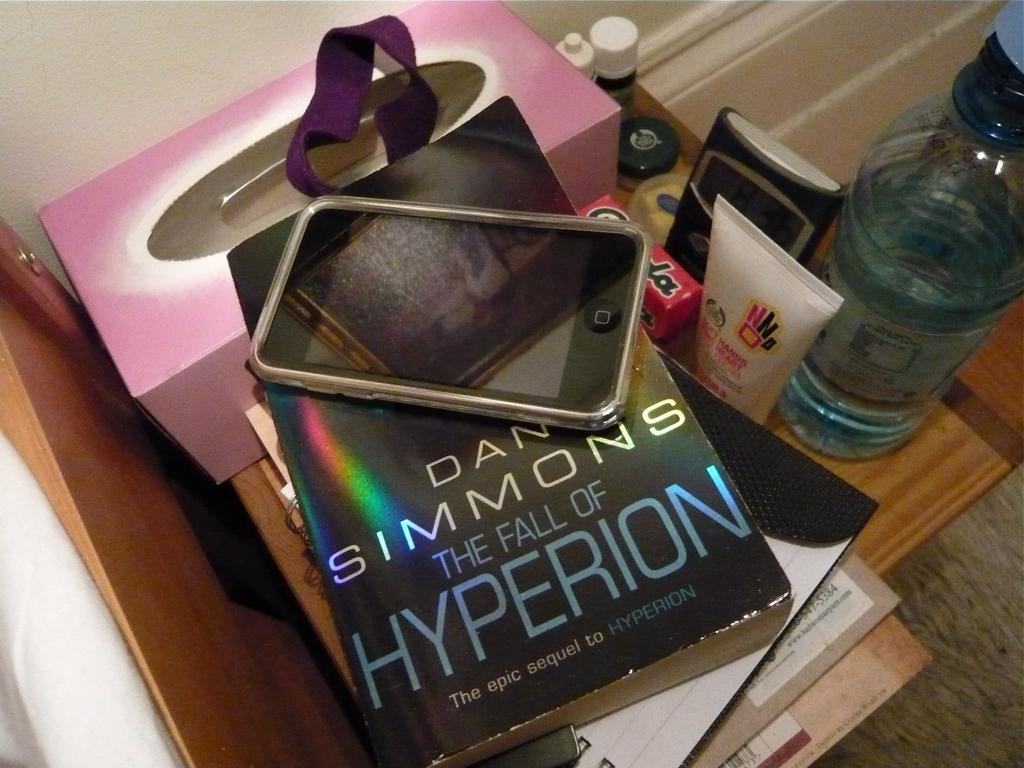Provide a one-sentence caption for the provided image. Book called The Fall of Hyperion by Dan Simmons under a phone. 